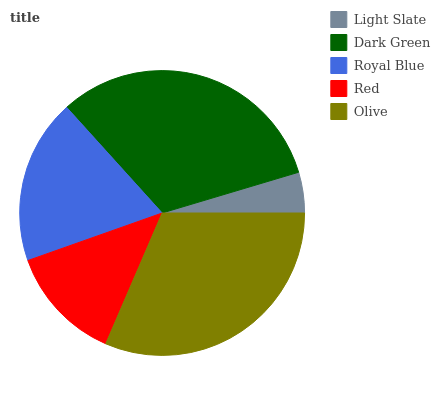Is Light Slate the minimum?
Answer yes or no. Yes. Is Dark Green the maximum?
Answer yes or no. Yes. Is Royal Blue the minimum?
Answer yes or no. No. Is Royal Blue the maximum?
Answer yes or no. No. Is Dark Green greater than Royal Blue?
Answer yes or no. Yes. Is Royal Blue less than Dark Green?
Answer yes or no. Yes. Is Royal Blue greater than Dark Green?
Answer yes or no. No. Is Dark Green less than Royal Blue?
Answer yes or no. No. Is Royal Blue the high median?
Answer yes or no. Yes. Is Royal Blue the low median?
Answer yes or no. Yes. Is Dark Green the high median?
Answer yes or no. No. Is Olive the low median?
Answer yes or no. No. 